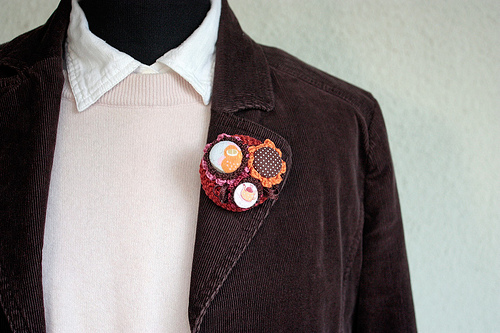<image>
Can you confirm if the teapot is on the jacket? Yes. Looking at the image, I can see the teapot is positioned on top of the jacket, with the jacket providing support. 